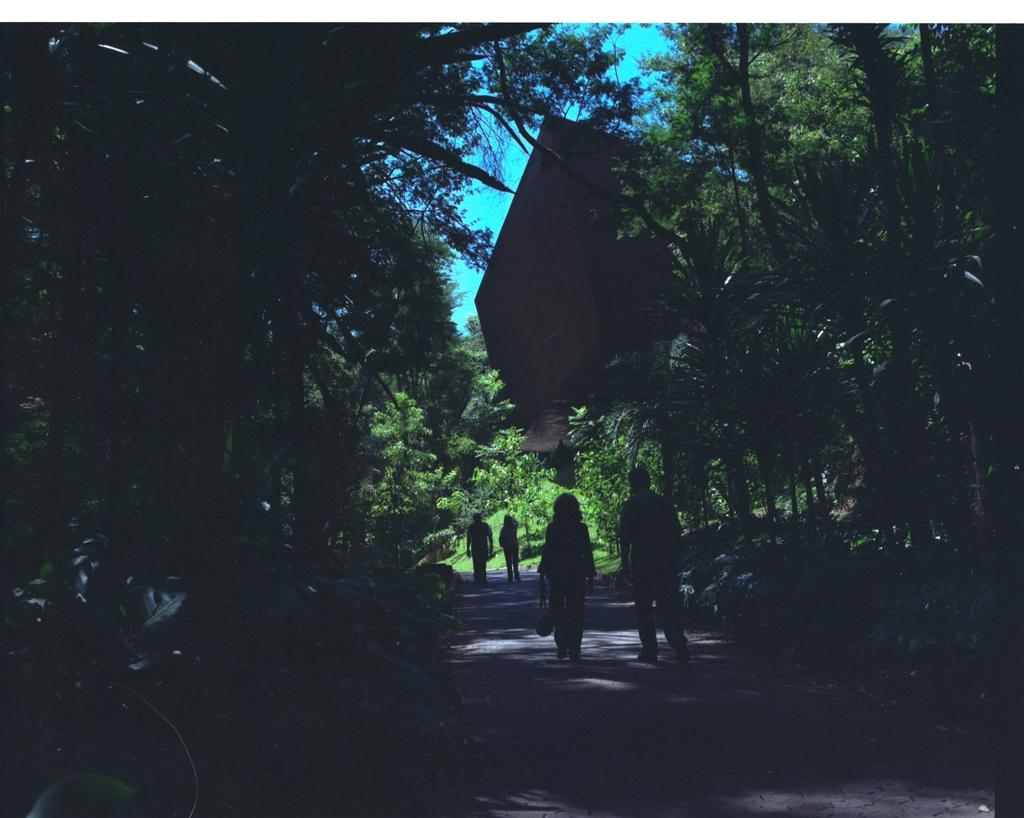How many people are walking on the road in the image? There are four people walking on the road in the image. What can be seen in the background of the image? In the background of the image, there are plants, trees, a building, and the sky. Can you describe the natural elements visible in the image? The natural elements visible in the image include plants and trees. What news is being discussed by the people walking on the road in the image? There is no indication in the image that the people are discussing any news, as their actions and expressions are not visible. 